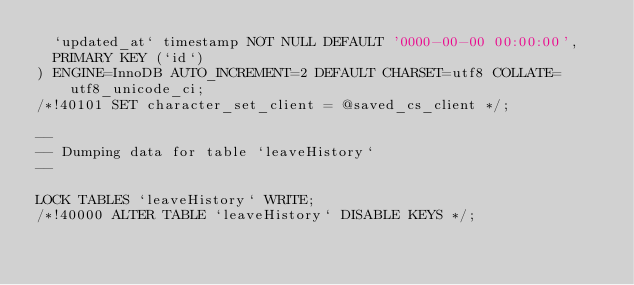Convert code to text. <code><loc_0><loc_0><loc_500><loc_500><_SQL_>  `updated_at` timestamp NOT NULL DEFAULT '0000-00-00 00:00:00',
  PRIMARY KEY (`id`)
) ENGINE=InnoDB AUTO_INCREMENT=2 DEFAULT CHARSET=utf8 COLLATE=utf8_unicode_ci;
/*!40101 SET character_set_client = @saved_cs_client */;

--
-- Dumping data for table `leaveHistory`
--

LOCK TABLES `leaveHistory` WRITE;
/*!40000 ALTER TABLE `leaveHistory` DISABLE KEYS */;</code> 